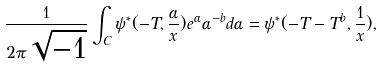<formula> <loc_0><loc_0><loc_500><loc_500>\frac { 1 } { 2 \pi \sqrt { - 1 } } \int _ { C } \psi ^ { * } ( - { T } , \frac { \alpha } { x } ) e ^ { \alpha } { \alpha } ^ { - b } d \alpha = \psi ^ { * } ( - { T } - { T } ^ { b } , \frac { 1 } { x } ) ,</formula> 